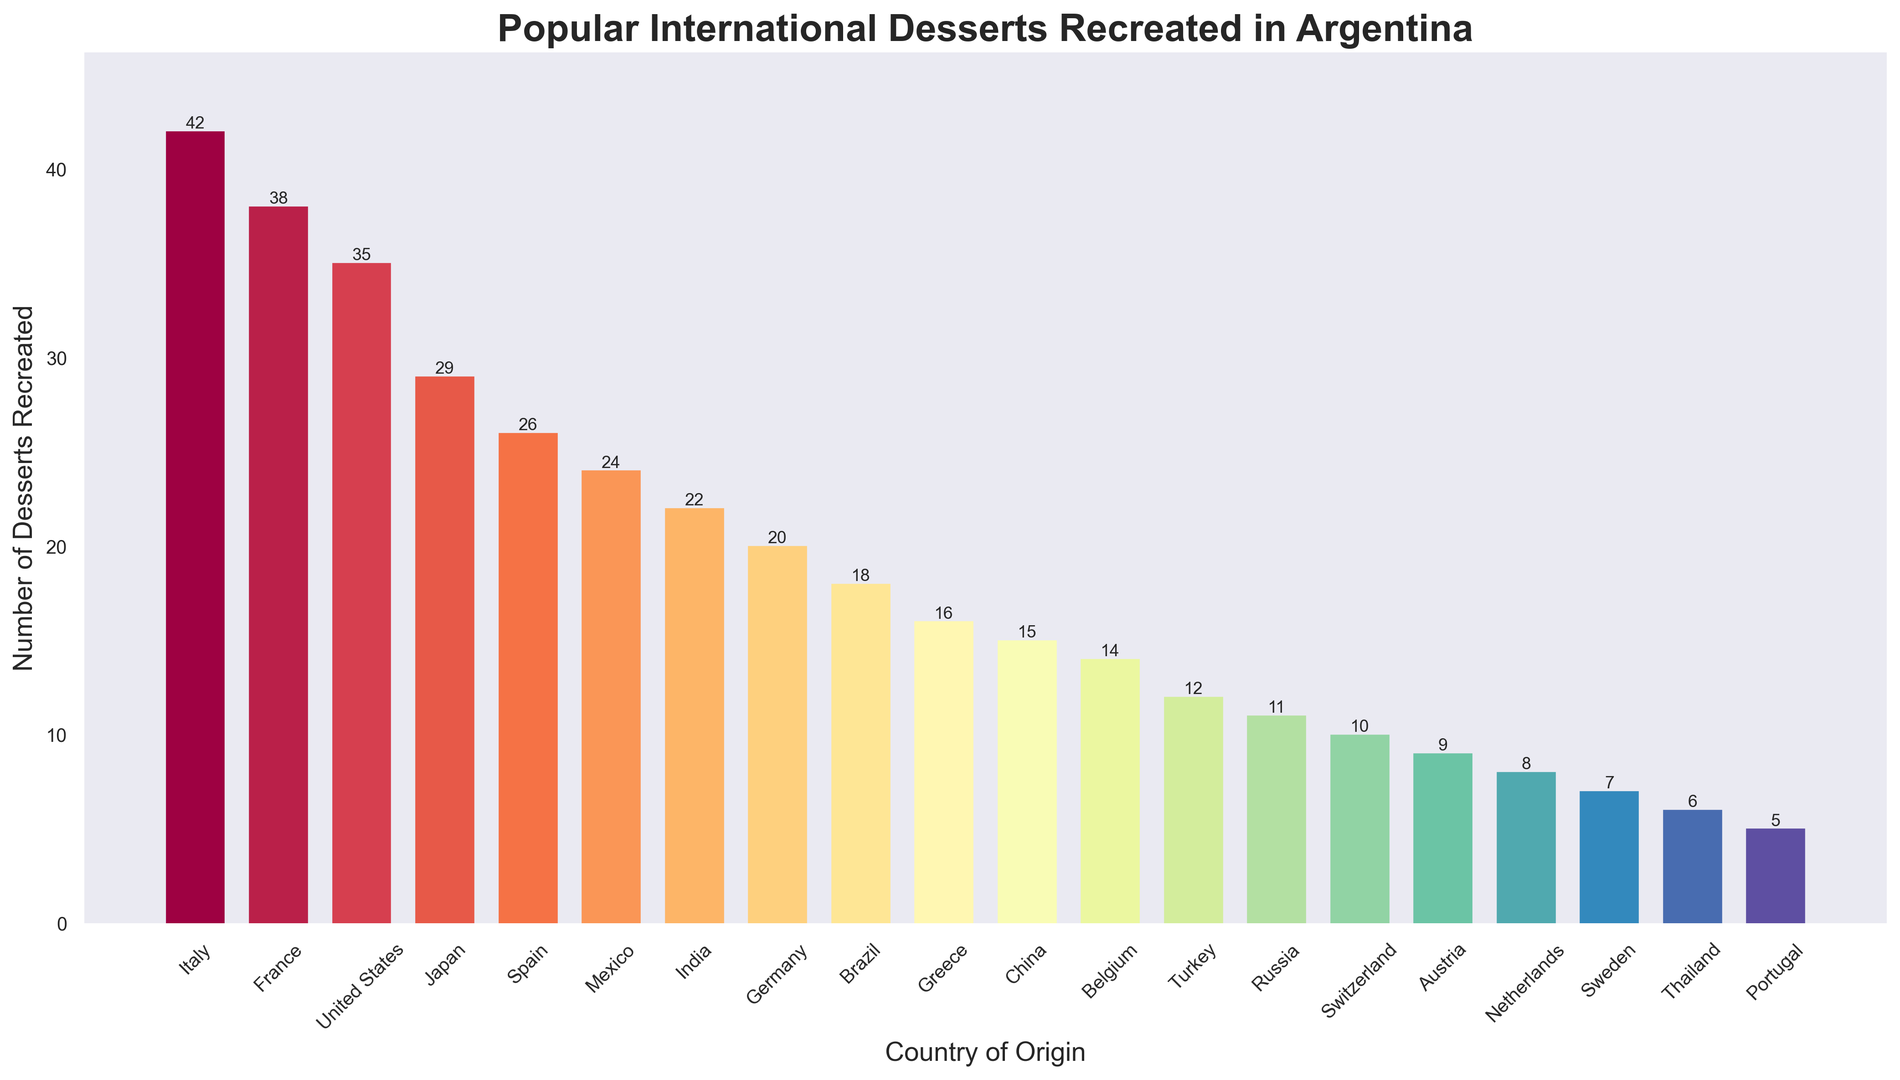How many more desserts from Italy are recreated compared to Germany? Italy has 42 desserts recreated and Germany has 20. The difference is 42 - 20 = 22.
Answer: 22 Which country has the second highest number of desserts recreated in Argentina? The top country is Italy with 42 desserts, and the second highest is France with 38 desserts recreated.
Answer: France What is the average number of desserts recreated for the top 5 countries? The top 5 countries are Italy (42), France (38), United States (35), Japan (29), and Spain (26). Calculate the sum: 42 + 38 + 35 + 29 + 26 = 170. The average is 170 / 5 = 34.
Answer: 34 How many countries have fewer than 20 desserts recreated? Count the countries with values less than 20: Brazil (18), Greece (16), China (15), Belgium (14), Turkey (12), Russia (11), Switzerland (10), Austria (9), Netherlands (8), Sweden (7), Thailand (6), Portugal (5). There are 12 such countries.
Answer: 12 Are there more desserts recreated from Asia or Europe? Asia: Japan (29), India (22), China (15), Thailand (6) = 72 desserts. Europe: Italy (42), France (38), Spain (26), Germany (20), Greece (16), Belgium (14), Turkey (12), Russia (11), Switzerland (10), Austria (9), Netherlands (8), Sweden (7), Portugal (5) = 218 desserts. There are more from Europe.
Answer: Europe What is the combined total number of desserts recreated from the United States and Mexico? United States has 35 and Mexico has 24. The sum is 35 + 24 = 59.
Answer: 59 How many desserts are recreated from countries originating outside of Europe (non-European countries)? Non-European countries: United States (35), Japan (29), Mexico (24), India (22), Brazil (18), China (15), Turkey (12), Russia (11), Thailand (6) = 172.
Answer: 172 